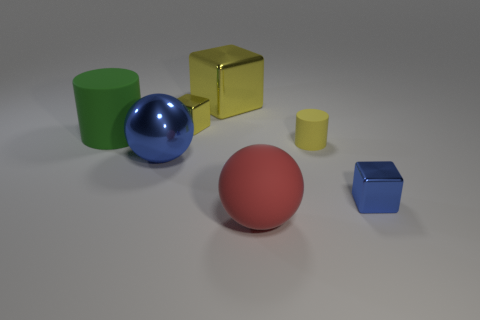Subtract all small cubes. How many cubes are left? 1 Subtract all cubes. How many objects are left? 4 Add 3 large yellow metal cubes. How many objects exist? 10 Add 2 red rubber spheres. How many red rubber spheres are left? 3 Add 1 small cyan matte objects. How many small cyan matte objects exist? 1 Subtract 0 blue cylinders. How many objects are left? 7 Subtract all tiny purple metal balls. Subtract all tiny cubes. How many objects are left? 5 